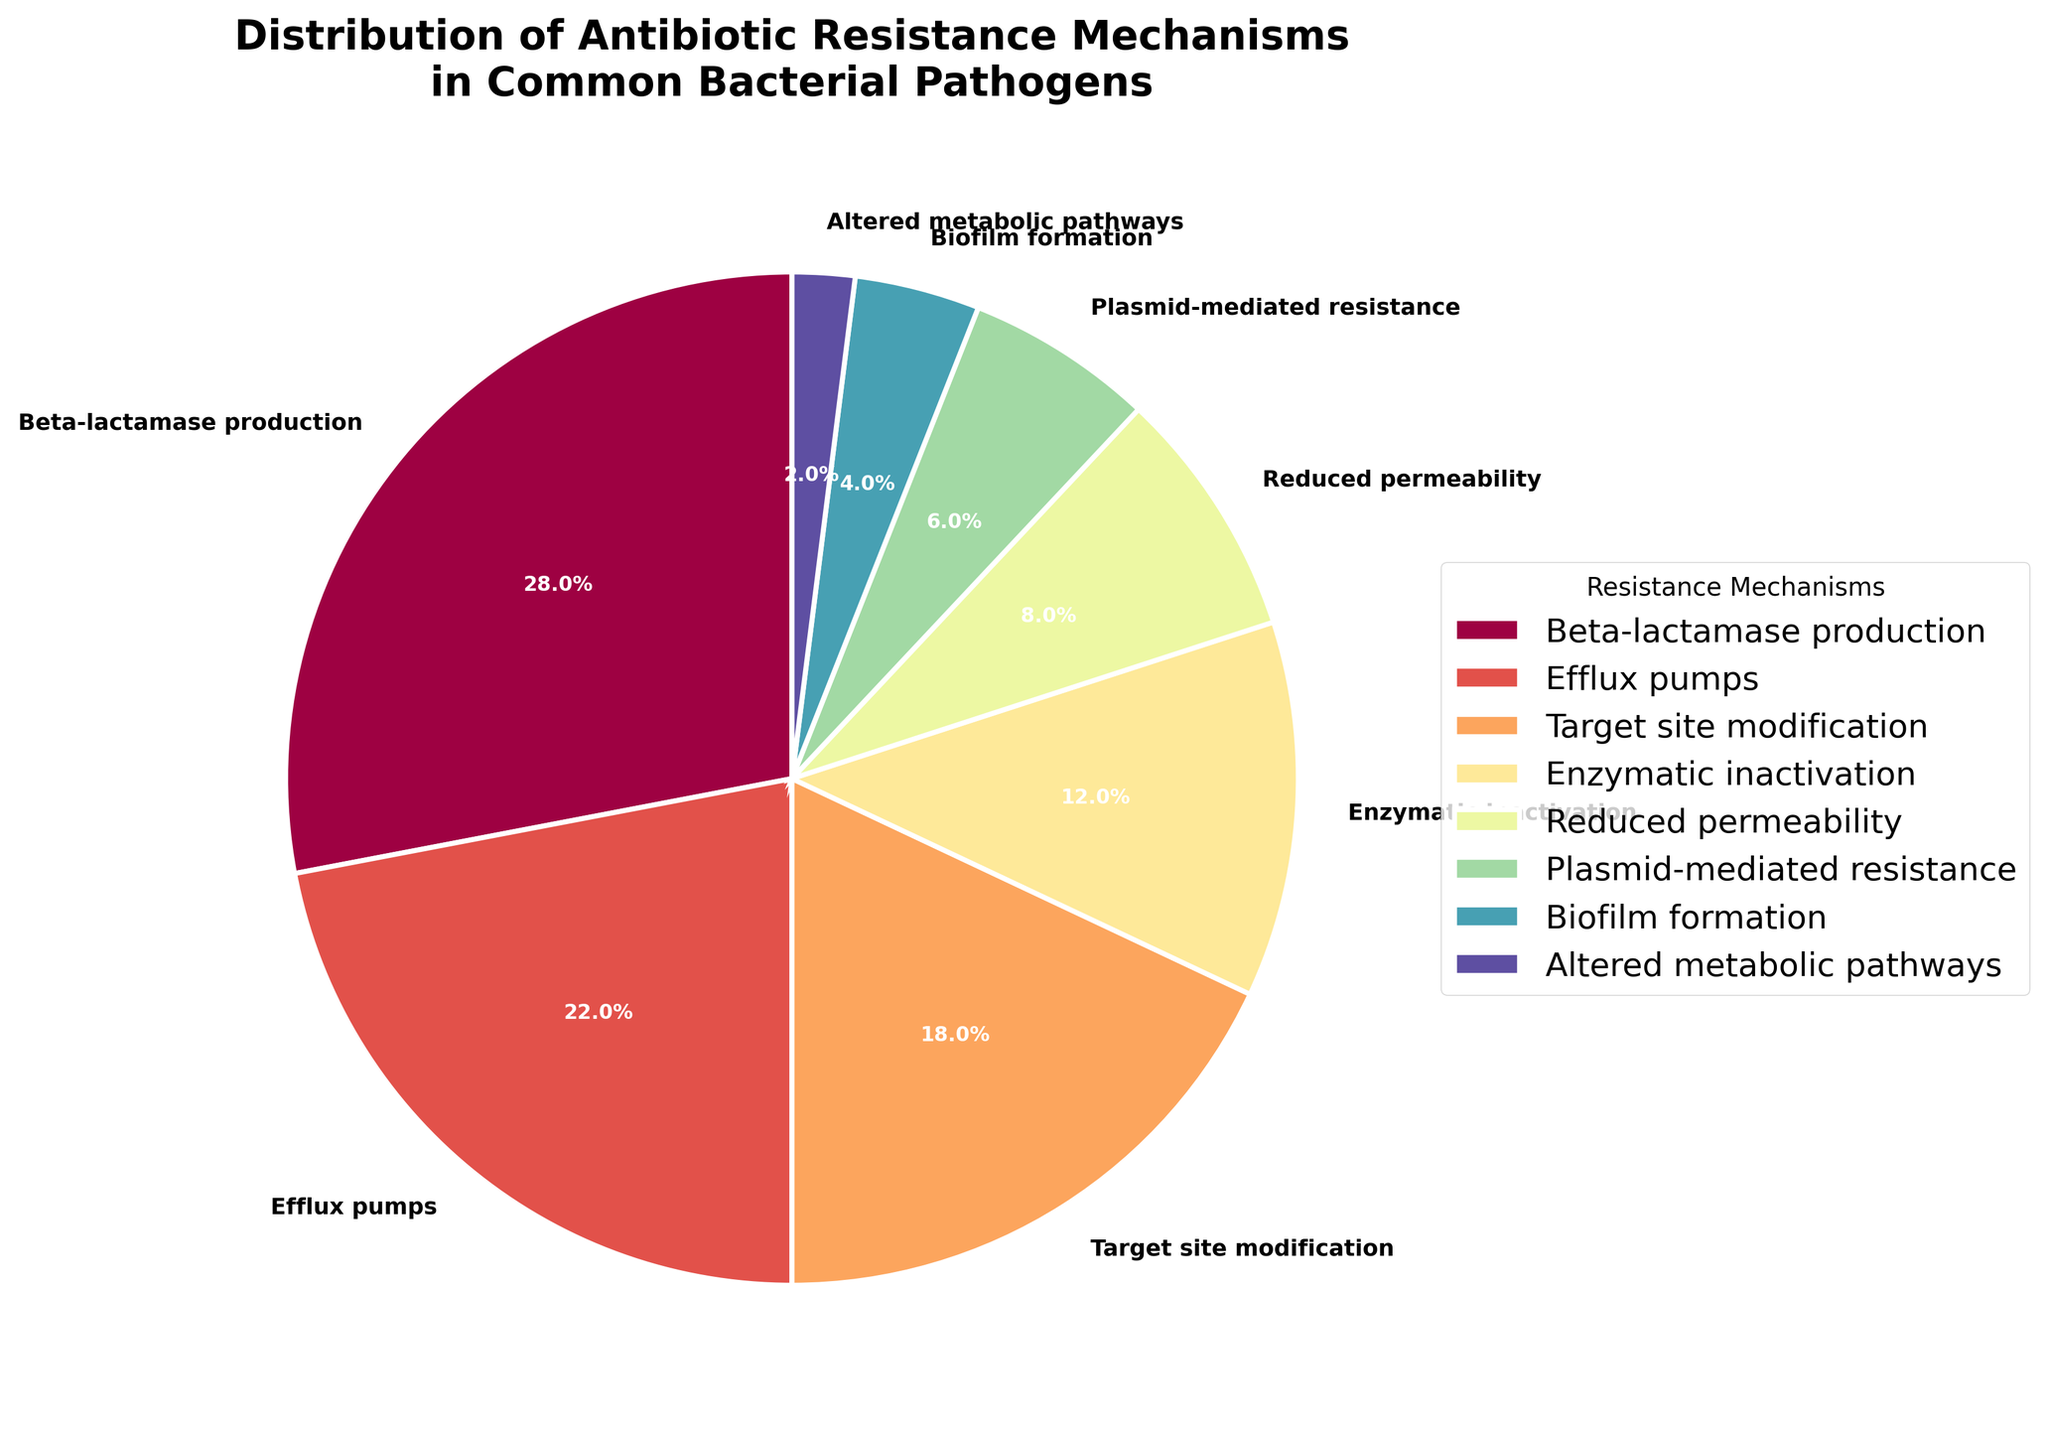What portion of the pie chart is occupied by Beta-lactamase production compared to Efflux pumps? Beta-lactamase production occupies 28% of the pie chart, whereas Efflux pumps occupy 22%. Comparing the two, Beta-lactamase production occupies a larger portion.
Answer: Beta-lactamase production Which mechanism has the smallest percentage of distribution? The mechanism with the smallest percentage of distribution is identified by looking at the segment of the pie chart with the lowest value. Altered metabolic pathways have the smallest percentage at 2%.
Answer: Altered metabolic pathways How much larger is the percentage of Beta-lactamase production compared to the combined percentage of Biofilm formation and Plasmid-mediated resistance? Biofilm formation accounts for 4%, while Plasmid-mediated resistance accounts for 6%. The combined percentage is 4% + 6% = 10%. The percentage of Beta-lactamase production is 28%. The difference between the two is 28% - 10% = 18%.
Answer: 18% What is the combined percentage of the top three resistance mechanisms? The top three resistance mechanisms are Beta-lactamase production (28%), Efflux pumps (22%), and Target site modification (18%). The combined percentage is 28% + 22% + 18% = 68%.
Answer: 68% Does Enzymatic inactivation account for a greater percentage than Reduced permeability? Enzymatic inactivation accounts for 12%, while Reduced permeability accounts for 8%. Comparing the two percentages, Enzymatic inactivation indeed accounts for a greater percentage.
Answer: Yes Which resistance mechanism represents almost one-fifth of the total distribution? Target site modification represents 18%, which is approximately one-fifth (20%) of the total distribution.
Answer: Target site modification How does the percentage of Efflux pumps compare to the combined percentage of Reduced permeability and Plasmid-mediated resistance? Efflux pumps account for 22%. Reduced permeability and Plasmid-mediated resistance together account for 8% + 6% = 14%. Efflux pumps have a higher percentage compared to the combined percentage of Reduced permeability and Plasmid-mediated resistance.
Answer: Efflux pumps Which segment in the pie chart has a light blue color? Based on the generated pie chart, Enzymatic inactivation is represented by a light blue color segment.
Answer: Enzymatic inactivation What is the average percentage of the resistance mechanisms whose values are below 10%? The mechanisms with percentages below 10% are Reduced permeability (8%), Plasmid-mediated resistance (6%), Biofilm formation (4%), and Altered metabolic pathways (2%). To find the average: (8 + 6 + 4 + 2) / 4 = 20 / 4 = 5%.
Answer: 5% 